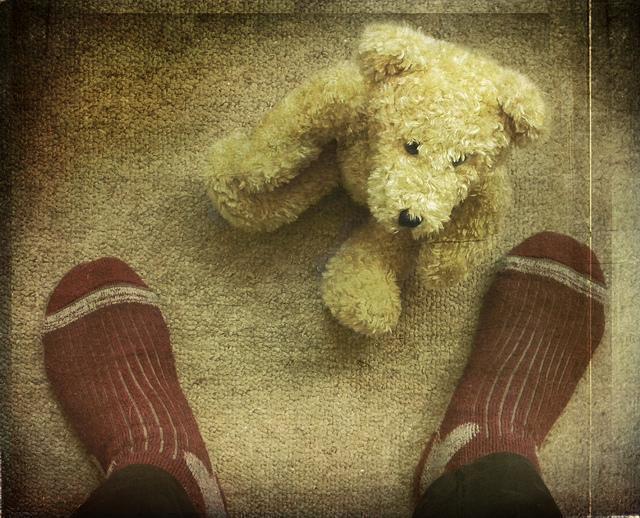Is the given caption "The teddy bear is touching the person." fitting for the image?
Answer yes or no. No. Is the statement "The teddy bear is beneath the person." accurate regarding the image?
Answer yes or no. Yes. 